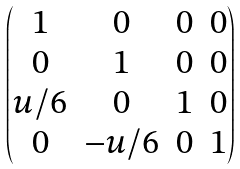<formula> <loc_0><loc_0><loc_500><loc_500>\begin{pmatrix} 1 & 0 & 0 & 0 \\ 0 & 1 & 0 & 0 \\ u / 6 & 0 & 1 & 0 \\ 0 & - u / 6 & 0 & 1 \end{pmatrix}</formula> 